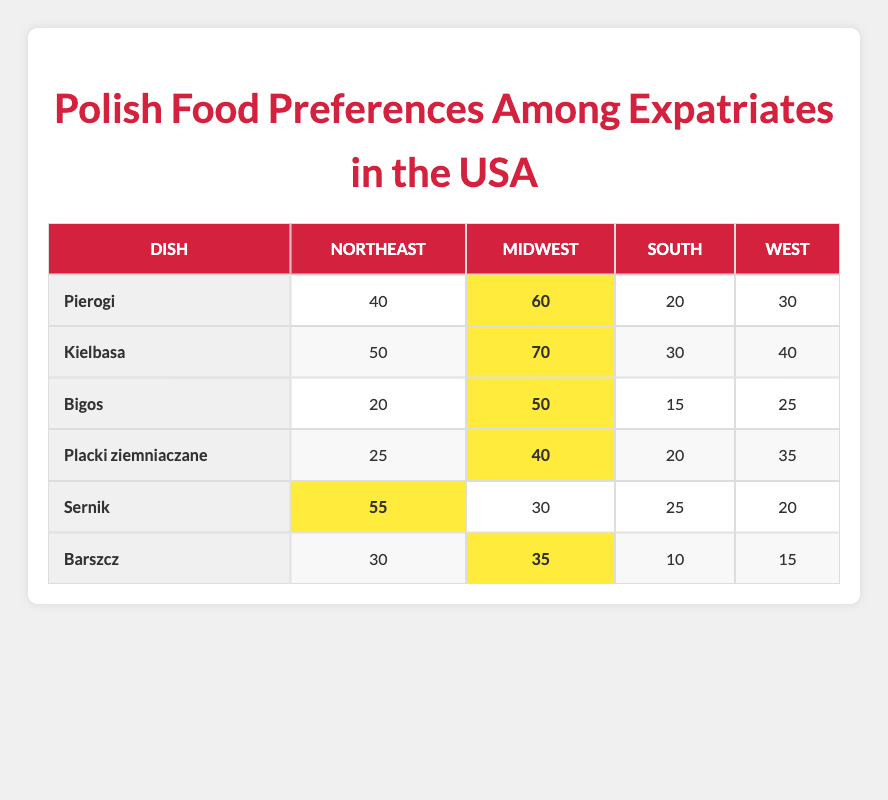What is the preference for Pierogi in the Midwest? The table shows that the preference for Pierogi in the Midwest is 60.
Answer: 60 Which dish has the highest popularity in the Northeast? By examining the Northeast column, Sernik has the highest value of 55 compared to other dishes.
Answer: Sernik Is the preference for Bigos higher in the Midwest than in the South? The value for Bigos in the Midwest is 50, while in the South it is only 15, indicating that the preference for Bigos is indeed higher in the Midwest.
Answer: Yes What is the total preference for Kielbasa across all regions? Adding the values for Kielbasa: 50 (Northeast) + 70 (Midwest) + 30 (South) + 40 (West) equals 190.
Answer: 190 In which region is the preference for Barszcz the lowest? The preference for Barszcz in the South is the lowest at 10 compared to other regions: 30 (Northeast), 35 (Midwest), and 15 (West).
Answer: South What is the average preference for Placki ziemniaczane across all regions? Adding the preferences: 25 (Northeast) + 40 (Midwest) + 20 (South) + 35 (West) equals 120. The average is 120 divided by 4, which is 30.
Answer: 30 Is the preference for Sernik in the Midwest higher than that for Kielbasa in the South? Sernik's preference in the Midwest is 30, whereas Kielbasa's preference in the South is 30 as well, making them equal.
Answer: No Which dish has the greatest difference in preference between the Midwest and the South? Calculating the differences: Kielbasa (70 - 30 = 40), Bigos (50 - 15 = 35), and others show that Kielbasa has the greatest difference of 40.
Answer: Kielbasa 